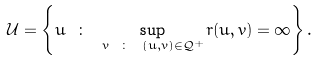Convert formula to latex. <formula><loc_0><loc_0><loc_500><loc_500>\mathcal { U } = \left \{ u \ \colon \ \sup _ { v \ \colon \ ( u , v ) \in \mathcal { Q } ^ { + } } r ( u , v ) = \infty \right \} .</formula> 